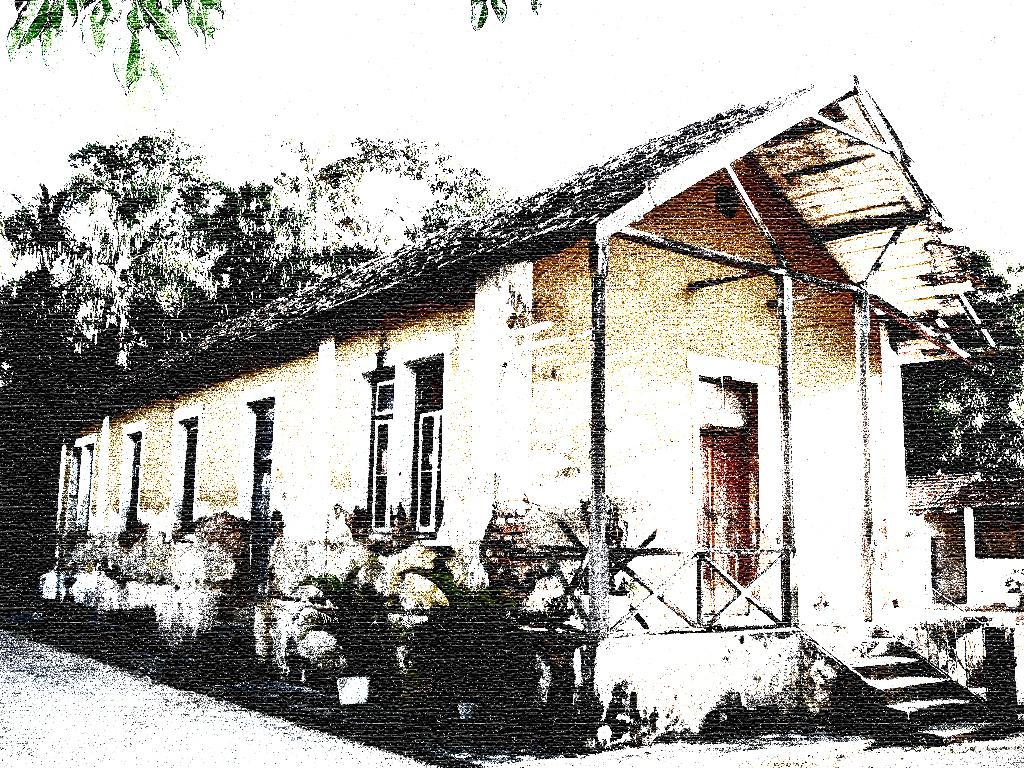What is the main subject in the center of the image? There is a house in the center of the image. What can be seen on the left side of the house? There are plants on the left side of the house. What is visible in the background of the image? There are trees and the sky. Can you see a pencil being used by the sheep in the hat in the image? There is no pencil, sheep, or hat present in the image. 